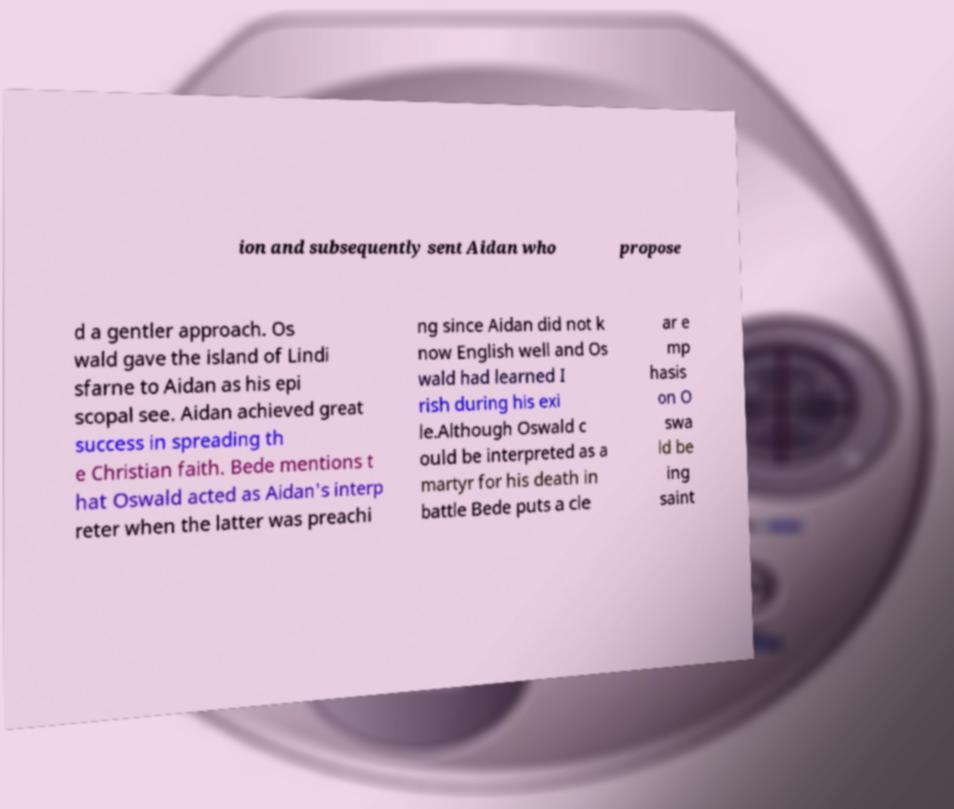Can you read and provide the text displayed in the image?This photo seems to have some interesting text. Can you extract and type it out for me? ion and subsequently sent Aidan who propose d a gentler approach. Os wald gave the island of Lindi sfarne to Aidan as his epi scopal see. Aidan achieved great success in spreading th e Christian faith. Bede mentions t hat Oswald acted as Aidan's interp reter when the latter was preachi ng since Aidan did not k now English well and Os wald had learned I rish during his exi le.Although Oswald c ould be interpreted as a martyr for his death in battle Bede puts a cle ar e mp hasis on O swa ld be ing saint 